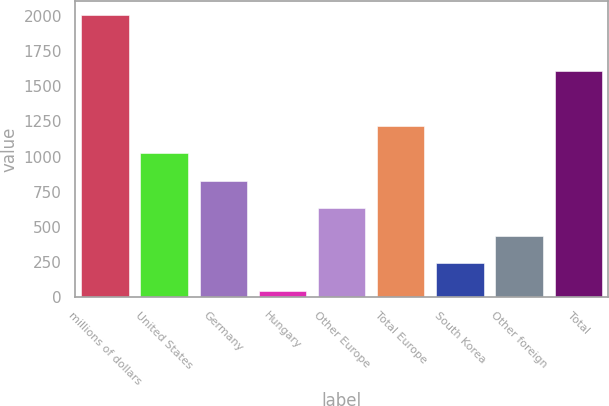Convert chart to OTSL. <chart><loc_0><loc_0><loc_500><loc_500><bar_chart><fcel>millions of dollars<fcel>United States<fcel>Germany<fcel>Hungary<fcel>Other Europe<fcel>Total Europe<fcel>South Korea<fcel>Other foreign<fcel>Total<nl><fcel>2007<fcel>1024.6<fcel>828.12<fcel>42.2<fcel>631.64<fcel>1221.08<fcel>238.68<fcel>435.16<fcel>1609.1<nl></chart> 